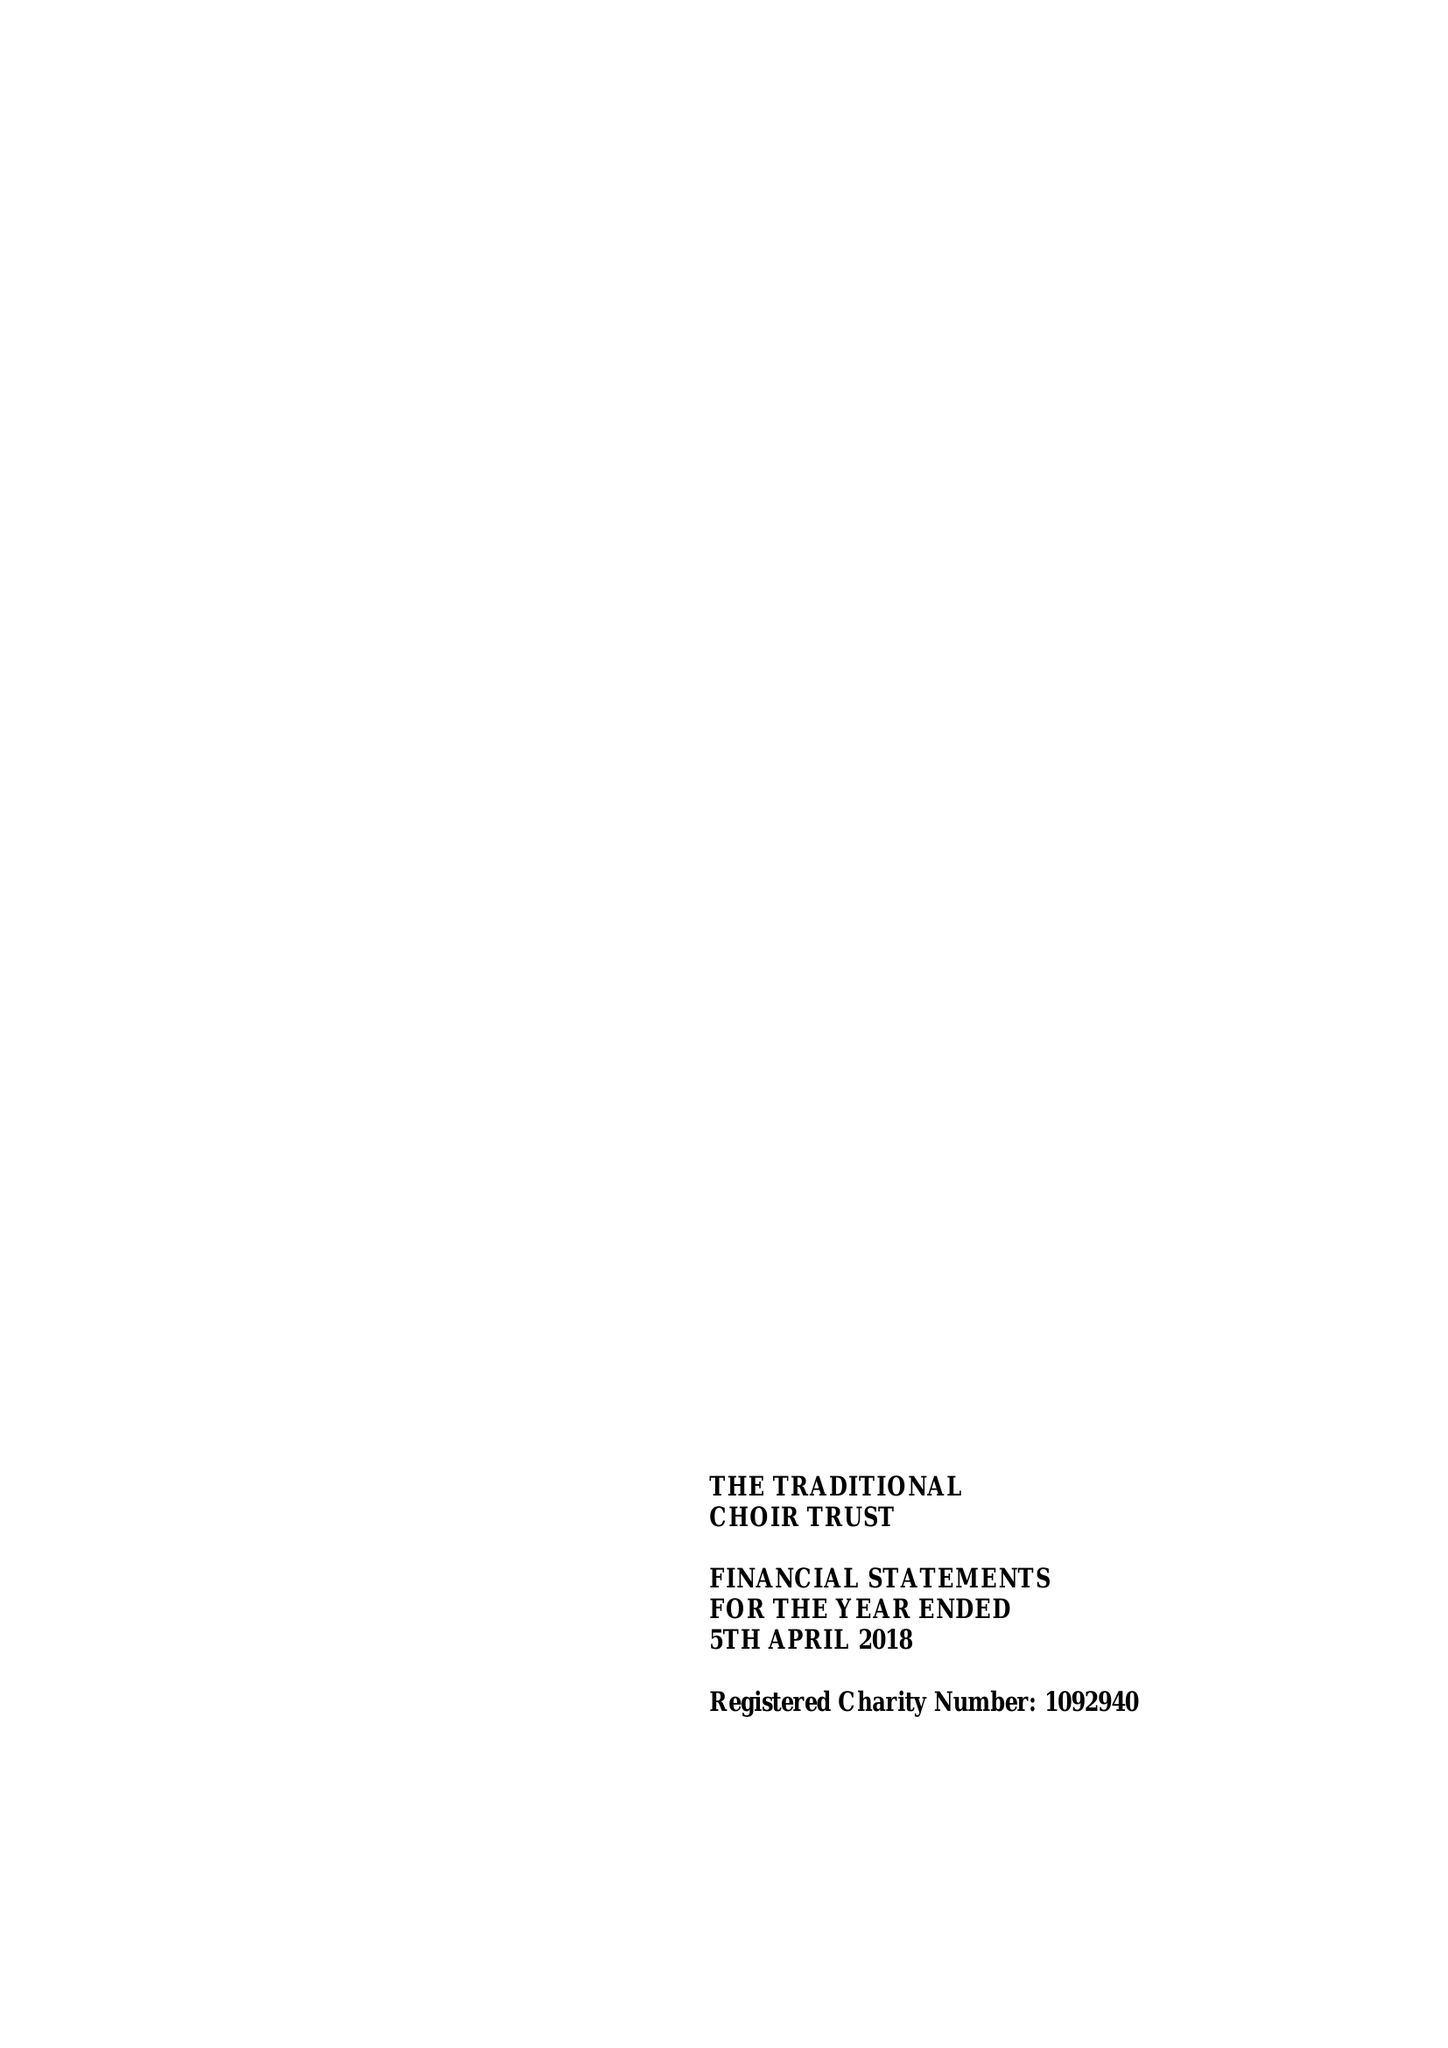What is the value for the charity_number?
Answer the question using a single word or phrase. 1092940 